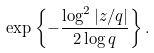Convert formula to latex. <formula><loc_0><loc_0><loc_500><loc_500>\exp \left \{ - \frac { \log ^ { 2 } | z / q | } { 2 \log q } \right \} .</formula> 